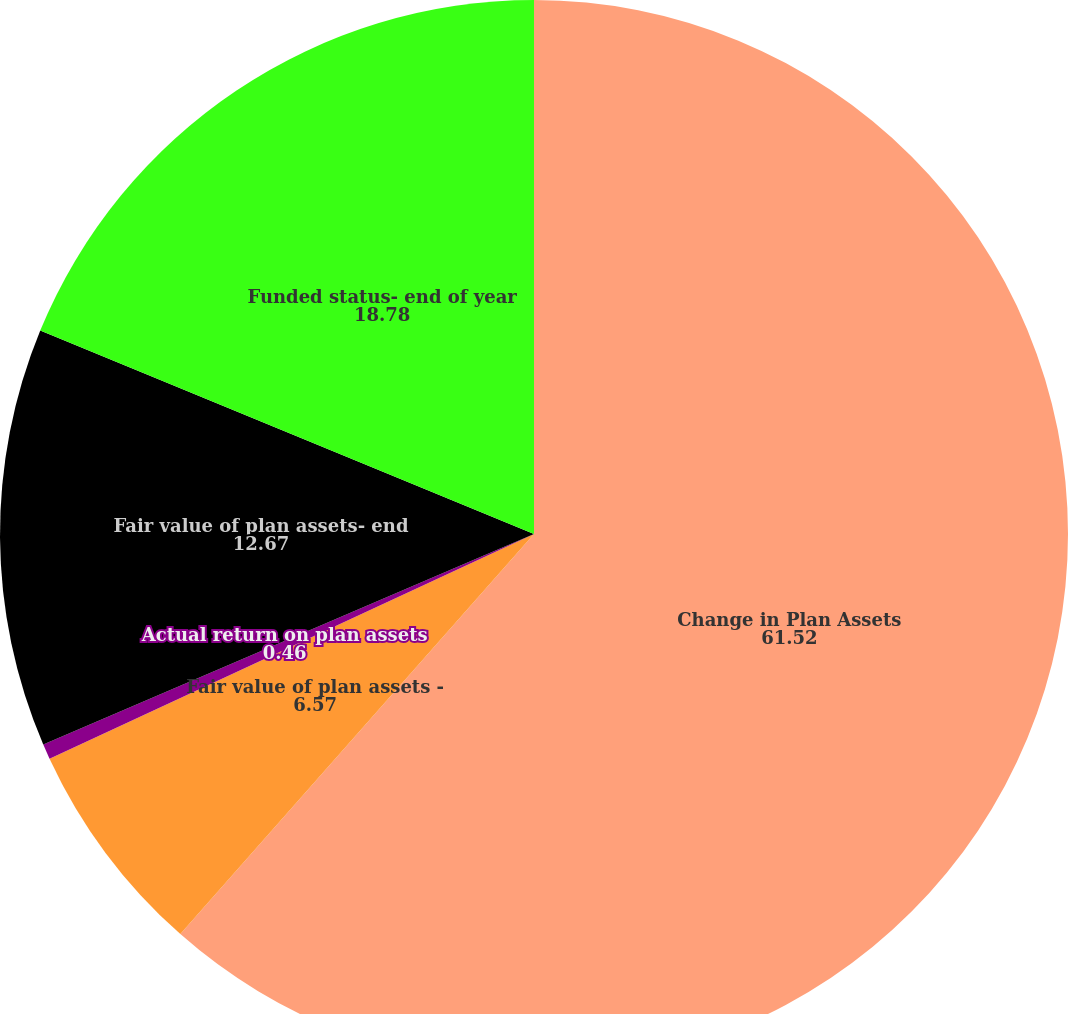Convert chart to OTSL. <chart><loc_0><loc_0><loc_500><loc_500><pie_chart><fcel>Change in Plan Assets<fcel>Fair value of plan assets -<fcel>Actual return on plan assets<fcel>Fair value of plan assets- end<fcel>Funded status- end of year<nl><fcel>61.52%<fcel>6.57%<fcel>0.46%<fcel>12.67%<fcel>18.78%<nl></chart> 